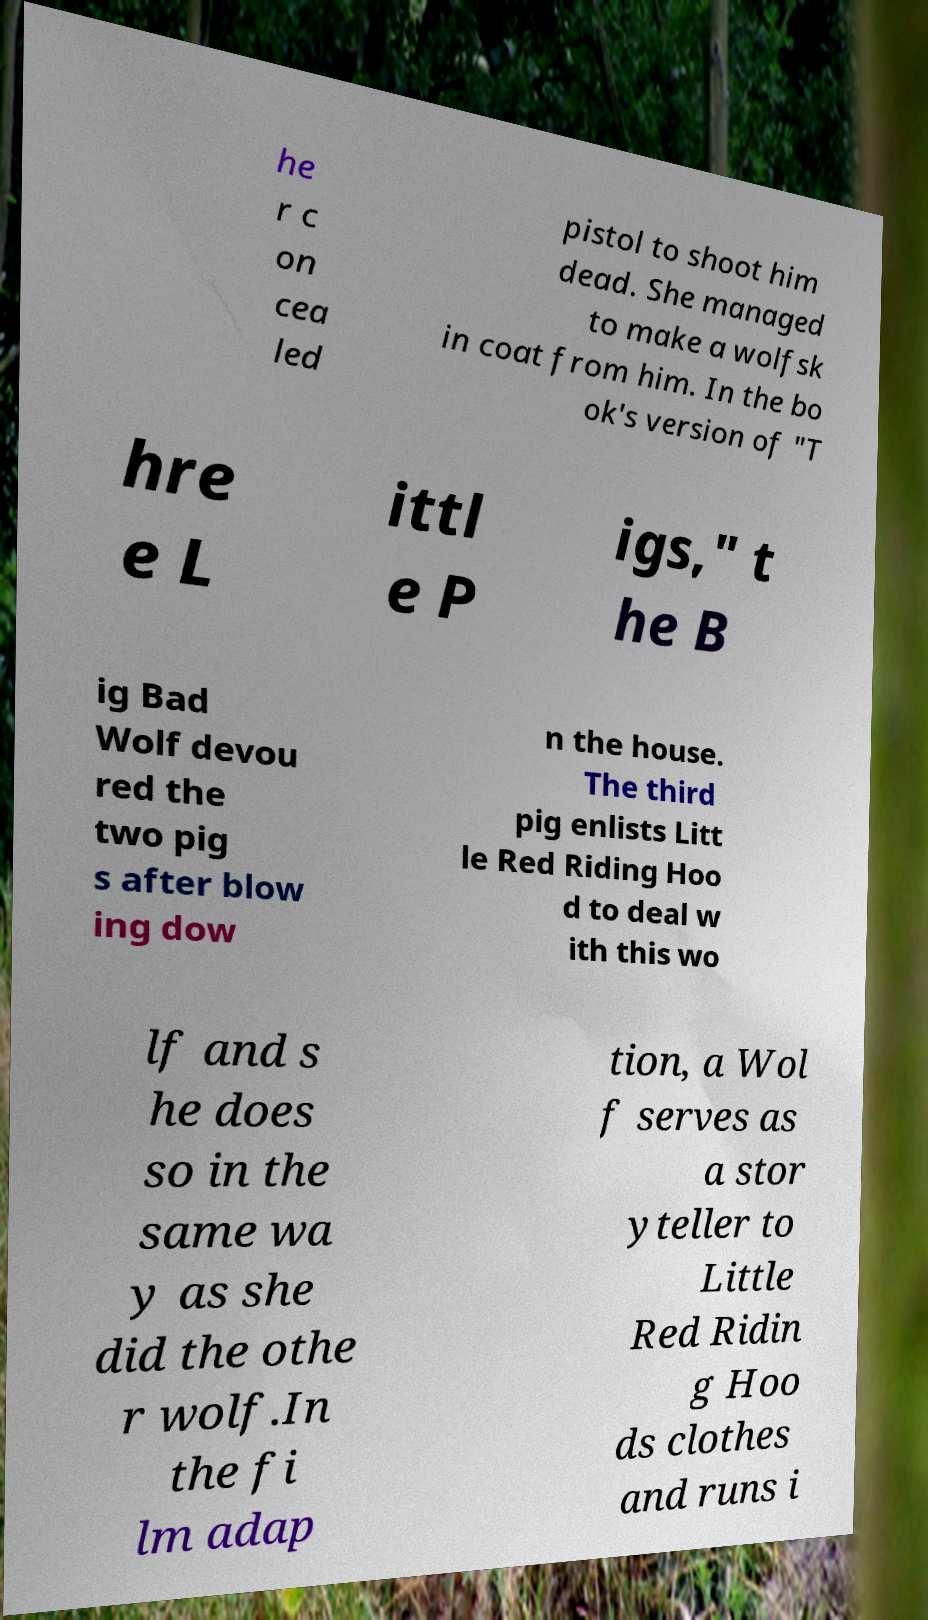Can you accurately transcribe the text from the provided image for me? he r c on cea led pistol to shoot him dead. She managed to make a wolfsk in coat from him. In the bo ok's version of "T hre e L ittl e P igs," t he B ig Bad Wolf devou red the two pig s after blow ing dow n the house. The third pig enlists Litt le Red Riding Hoo d to deal w ith this wo lf and s he does so in the same wa y as she did the othe r wolf.In the fi lm adap tion, a Wol f serves as a stor yteller to Little Red Ridin g Hoo ds clothes and runs i 